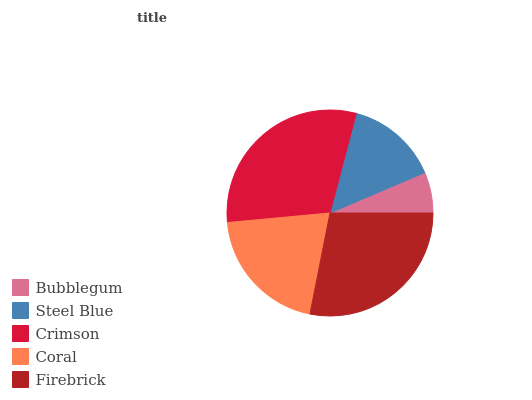Is Bubblegum the minimum?
Answer yes or no. Yes. Is Crimson the maximum?
Answer yes or no. Yes. Is Steel Blue the minimum?
Answer yes or no. No. Is Steel Blue the maximum?
Answer yes or no. No. Is Steel Blue greater than Bubblegum?
Answer yes or no. Yes. Is Bubblegum less than Steel Blue?
Answer yes or no. Yes. Is Bubblegum greater than Steel Blue?
Answer yes or no. No. Is Steel Blue less than Bubblegum?
Answer yes or no. No. Is Coral the high median?
Answer yes or no. Yes. Is Coral the low median?
Answer yes or no. Yes. Is Crimson the high median?
Answer yes or no. No. Is Bubblegum the low median?
Answer yes or no. No. 